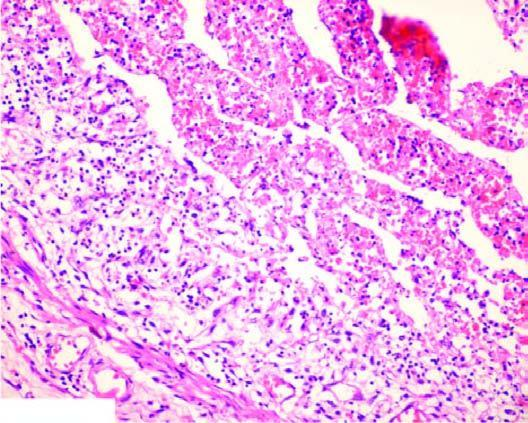what is there?
Answer the question using a single word or phrase. Acute panarteritis 